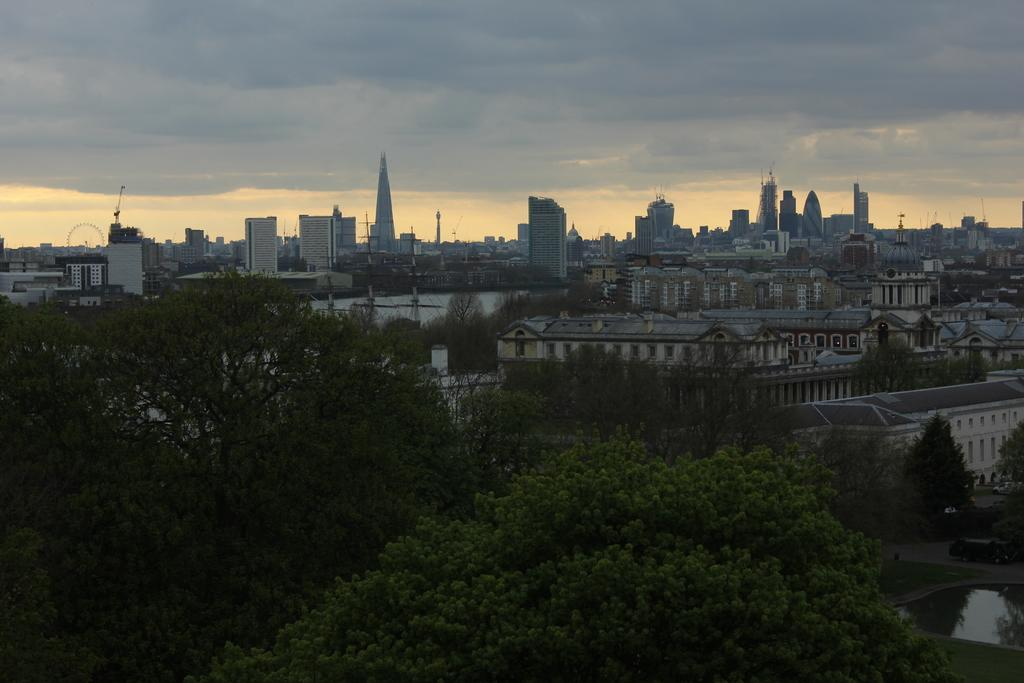What type of structures can be seen in the image? There are many houses and buildings in the image. What natural elements are present in the image? There are many trees and a grassy land in the image. How would you describe the sky in the image? The sky is cloudy in the image. What type of education can be seen taking place in the image? There is no indication of any educational activities taking place in the image. How many eggs are visible in the image? There are no eggs present in the image. 